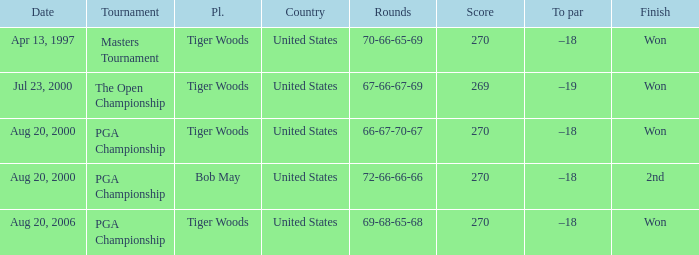What players finished 2nd? Bob May. 